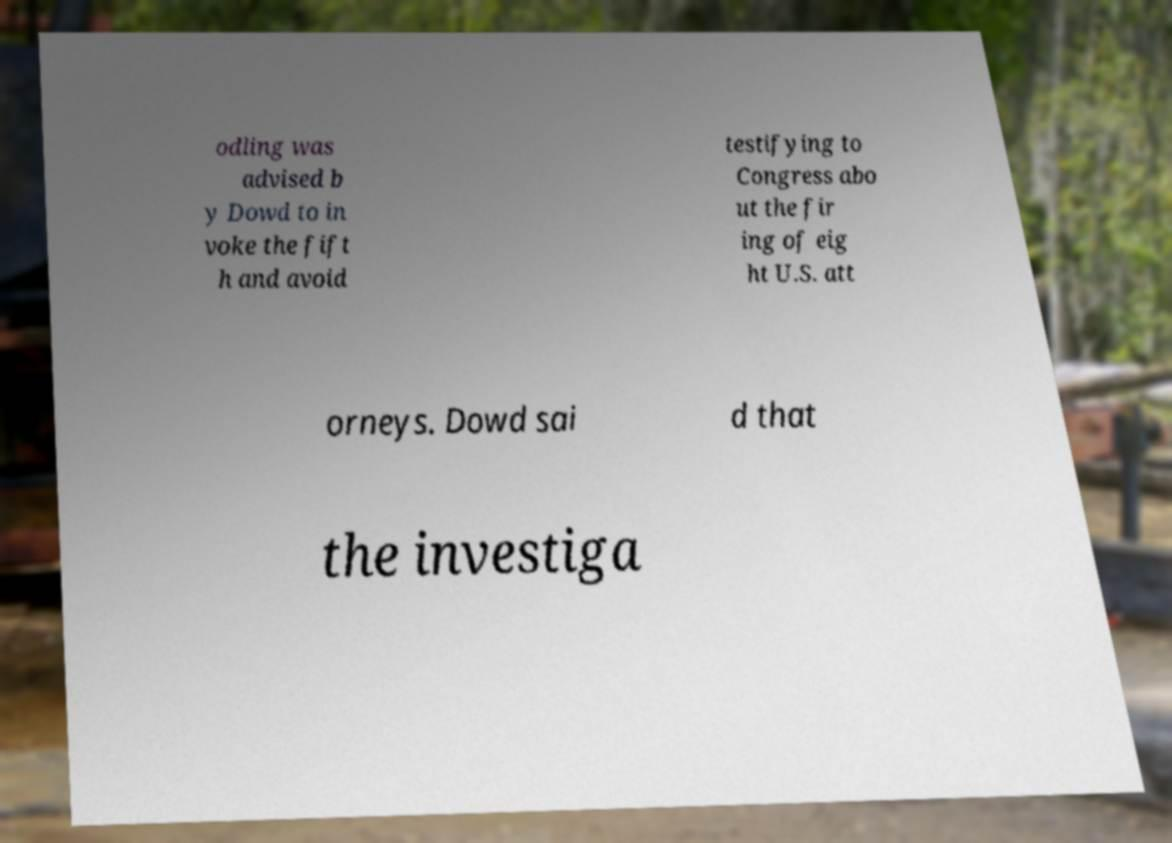Can you read and provide the text displayed in the image?This photo seems to have some interesting text. Can you extract and type it out for me? odling was advised b y Dowd to in voke the fift h and avoid testifying to Congress abo ut the fir ing of eig ht U.S. att orneys. Dowd sai d that the investiga 